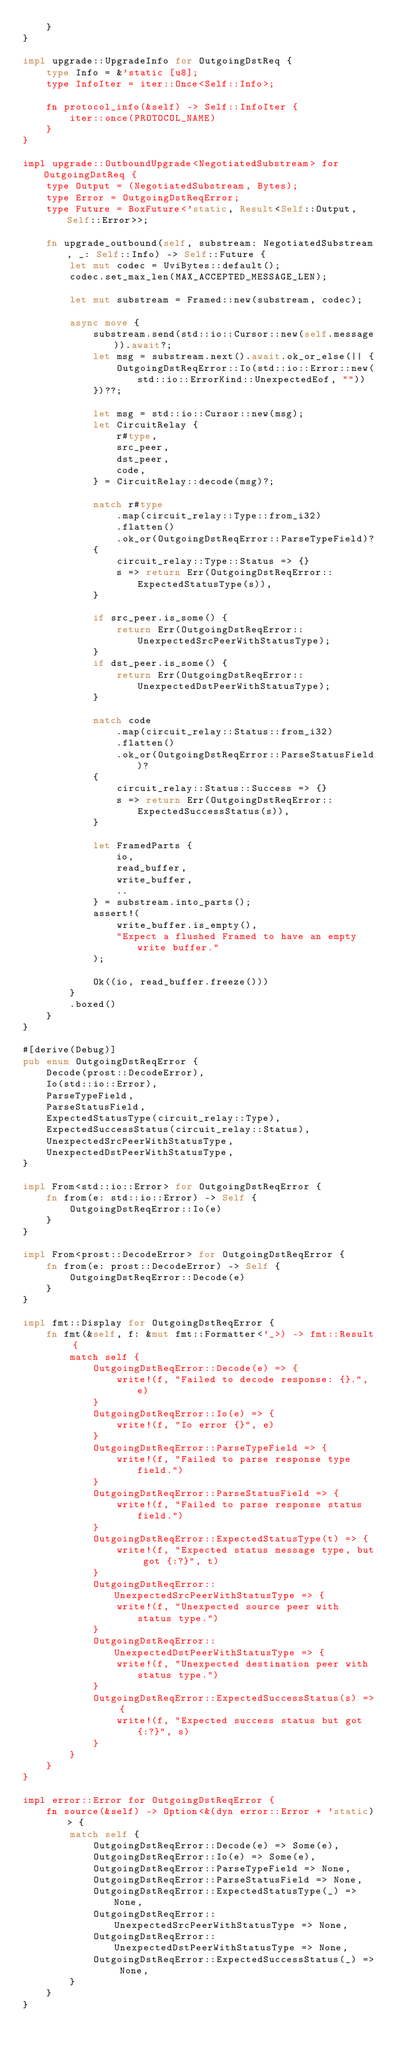<code> <loc_0><loc_0><loc_500><loc_500><_Rust_>    }
}

impl upgrade::UpgradeInfo for OutgoingDstReq {
    type Info = &'static [u8];
    type InfoIter = iter::Once<Self::Info>;

    fn protocol_info(&self) -> Self::InfoIter {
        iter::once(PROTOCOL_NAME)
    }
}

impl upgrade::OutboundUpgrade<NegotiatedSubstream> for OutgoingDstReq {
    type Output = (NegotiatedSubstream, Bytes);
    type Error = OutgoingDstReqError;
    type Future = BoxFuture<'static, Result<Self::Output, Self::Error>>;

    fn upgrade_outbound(self, substream: NegotiatedSubstream, _: Self::Info) -> Self::Future {
        let mut codec = UviBytes::default();
        codec.set_max_len(MAX_ACCEPTED_MESSAGE_LEN);

        let mut substream = Framed::new(substream, codec);

        async move {
            substream.send(std::io::Cursor::new(self.message)).await?;
            let msg = substream.next().await.ok_or_else(|| {
                OutgoingDstReqError::Io(std::io::Error::new(std::io::ErrorKind::UnexpectedEof, ""))
            })??;

            let msg = std::io::Cursor::new(msg);
            let CircuitRelay {
                r#type,
                src_peer,
                dst_peer,
                code,
            } = CircuitRelay::decode(msg)?;

            match r#type
                .map(circuit_relay::Type::from_i32)
                .flatten()
                .ok_or(OutgoingDstReqError::ParseTypeField)?
            {
                circuit_relay::Type::Status => {}
                s => return Err(OutgoingDstReqError::ExpectedStatusType(s)),
            }

            if src_peer.is_some() {
                return Err(OutgoingDstReqError::UnexpectedSrcPeerWithStatusType);
            }
            if dst_peer.is_some() {
                return Err(OutgoingDstReqError::UnexpectedDstPeerWithStatusType);
            }

            match code
                .map(circuit_relay::Status::from_i32)
                .flatten()
                .ok_or(OutgoingDstReqError::ParseStatusField)?
            {
                circuit_relay::Status::Success => {}
                s => return Err(OutgoingDstReqError::ExpectedSuccessStatus(s)),
            }

            let FramedParts {
                io,
                read_buffer,
                write_buffer,
                ..
            } = substream.into_parts();
            assert!(
                write_buffer.is_empty(),
                "Expect a flushed Framed to have an empty write buffer."
            );

            Ok((io, read_buffer.freeze()))
        }
        .boxed()
    }
}

#[derive(Debug)]
pub enum OutgoingDstReqError {
    Decode(prost::DecodeError),
    Io(std::io::Error),
    ParseTypeField,
    ParseStatusField,
    ExpectedStatusType(circuit_relay::Type),
    ExpectedSuccessStatus(circuit_relay::Status),
    UnexpectedSrcPeerWithStatusType,
    UnexpectedDstPeerWithStatusType,
}

impl From<std::io::Error> for OutgoingDstReqError {
    fn from(e: std::io::Error) -> Self {
        OutgoingDstReqError::Io(e)
    }
}

impl From<prost::DecodeError> for OutgoingDstReqError {
    fn from(e: prost::DecodeError) -> Self {
        OutgoingDstReqError::Decode(e)
    }
}

impl fmt::Display for OutgoingDstReqError {
    fn fmt(&self, f: &mut fmt::Formatter<'_>) -> fmt::Result {
        match self {
            OutgoingDstReqError::Decode(e) => {
                write!(f, "Failed to decode response: {}.", e)
            }
            OutgoingDstReqError::Io(e) => {
                write!(f, "Io error {}", e)
            }
            OutgoingDstReqError::ParseTypeField => {
                write!(f, "Failed to parse response type field.")
            }
            OutgoingDstReqError::ParseStatusField => {
                write!(f, "Failed to parse response status field.")
            }
            OutgoingDstReqError::ExpectedStatusType(t) => {
                write!(f, "Expected status message type, but got {:?}", t)
            }
            OutgoingDstReqError::UnexpectedSrcPeerWithStatusType => {
                write!(f, "Unexpected source peer with status type.")
            }
            OutgoingDstReqError::UnexpectedDstPeerWithStatusType => {
                write!(f, "Unexpected destination peer with status type.")
            }
            OutgoingDstReqError::ExpectedSuccessStatus(s) => {
                write!(f, "Expected success status but got {:?}", s)
            }
        }
    }
}

impl error::Error for OutgoingDstReqError {
    fn source(&self) -> Option<&(dyn error::Error + 'static)> {
        match self {
            OutgoingDstReqError::Decode(e) => Some(e),
            OutgoingDstReqError::Io(e) => Some(e),
            OutgoingDstReqError::ParseTypeField => None,
            OutgoingDstReqError::ParseStatusField => None,
            OutgoingDstReqError::ExpectedStatusType(_) => None,
            OutgoingDstReqError::UnexpectedSrcPeerWithStatusType => None,
            OutgoingDstReqError::UnexpectedDstPeerWithStatusType => None,
            OutgoingDstReqError::ExpectedSuccessStatus(_) => None,
        }
    }
}
</code> 